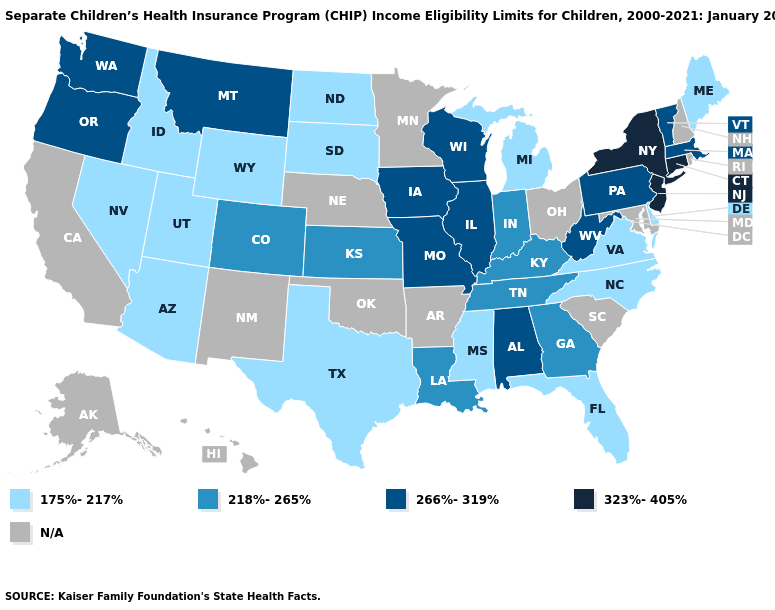Which states have the lowest value in the USA?
Give a very brief answer. Arizona, Delaware, Florida, Idaho, Maine, Michigan, Mississippi, Nevada, North Carolina, North Dakota, South Dakota, Texas, Utah, Virginia, Wyoming. Name the states that have a value in the range 218%-265%?
Concise answer only. Colorado, Georgia, Indiana, Kansas, Kentucky, Louisiana, Tennessee. Name the states that have a value in the range 218%-265%?
Write a very short answer. Colorado, Georgia, Indiana, Kansas, Kentucky, Louisiana, Tennessee. Which states hav the highest value in the Northeast?
Write a very short answer. Connecticut, New Jersey, New York. What is the value of New Mexico?
Keep it brief. N/A. Among the states that border Tennessee , which have the highest value?
Give a very brief answer. Alabama, Missouri. Name the states that have a value in the range N/A?
Write a very short answer. Alaska, Arkansas, California, Hawaii, Maryland, Minnesota, Nebraska, New Hampshire, New Mexico, Ohio, Oklahoma, Rhode Island, South Carolina. Among the states that border Maryland , which have the highest value?
Quick response, please. Pennsylvania, West Virginia. What is the value of North Carolina?
Give a very brief answer. 175%-217%. What is the lowest value in states that border Massachusetts?
Keep it brief. 266%-319%. What is the lowest value in states that border Massachusetts?
Give a very brief answer. 266%-319%. Does Connecticut have the highest value in the USA?
Answer briefly. Yes. What is the value of Michigan?
Keep it brief. 175%-217%. Name the states that have a value in the range 175%-217%?
Write a very short answer. Arizona, Delaware, Florida, Idaho, Maine, Michigan, Mississippi, Nevada, North Carolina, North Dakota, South Dakota, Texas, Utah, Virginia, Wyoming. Among the states that border Oregon , which have the highest value?
Short answer required. Washington. 